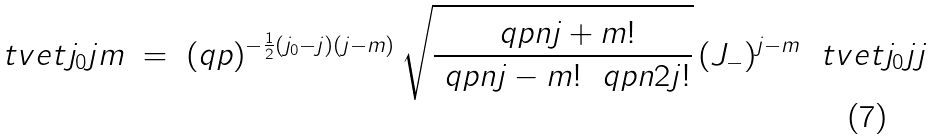<formula> <loc_0><loc_0><loc_500><loc_500>\ t v e t { j _ { 0 } } { j } { m } \ = \ ( q p ) ^ { - \frac { 1 } { 2 } ( j _ { 0 } - j ) ( j - m ) } \, \sqrt { \frac { \ q p n { j + m } ! } { \ q p n { j - m } ! \ \ q p n { 2 j } ! } } \, ( J _ { - } ) ^ { j - m } \ \ t v e t { j _ { 0 } } { j } { j }</formula> 